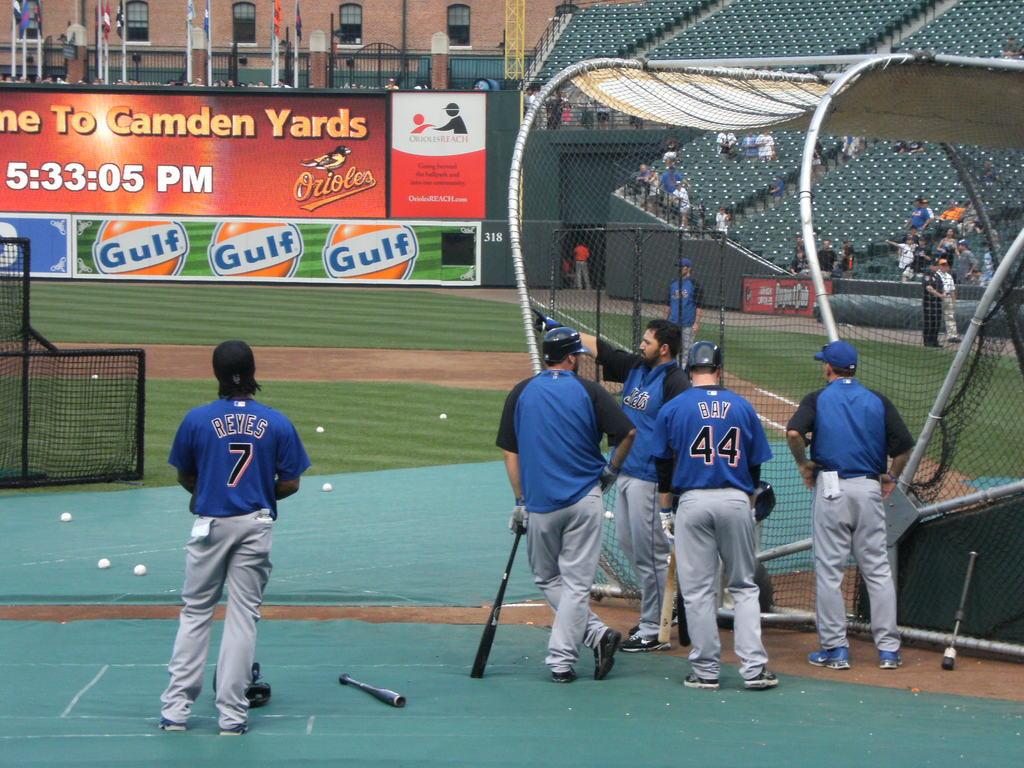What is the time?
Keep it short and to the point. 5:33:05. 